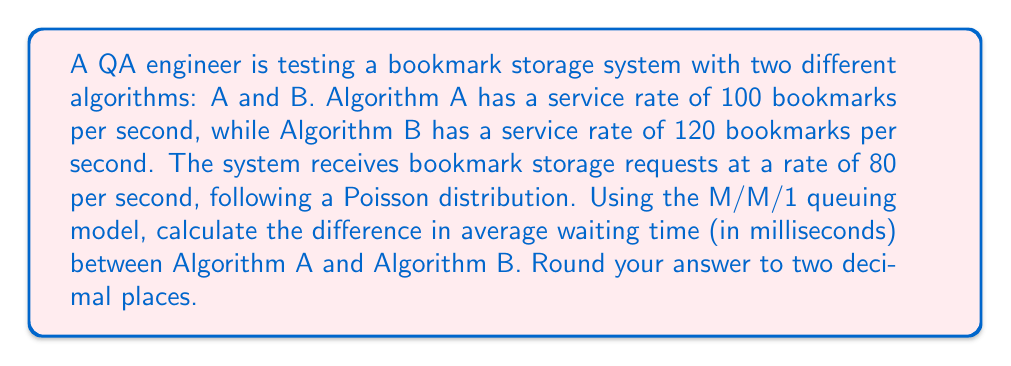Give your solution to this math problem. To solve this problem, we'll use the M/M/1 queuing model for each algorithm and compare their waiting times.

Step 1: Calculate the utilization factor (ρ) for each algorithm.
ρ = λ / μ, where λ is the arrival rate and μ is the service rate.

For Algorithm A: 
$$ \rho_A = \frac{80}{100} = 0.8 $$

For Algorithm B:
$$ \rho_B = \frac{80}{120} = \frac{2}{3} \approx 0.6667 $$

Step 2: Calculate the average waiting time (W) for each algorithm using the formula:
$$ W = \frac{\rho}{\mu(1-\rho)} $$

For Algorithm A:
$$ W_A = \frac{0.8}{100(1-0.8)} = \frac{0.8}{20} = 0.04 \text{ seconds} = 40 \text{ ms} $$

For Algorithm B:
$$ W_B = \frac{0.6667}{120(1-0.6667)} = \frac{0.6667}{40} = 0.016667 \text{ seconds} \approx 16.67 \text{ ms} $$

Step 3: Calculate the difference in waiting times.
$$ \text{Difference} = W_A - W_B = 40 - 16.67 = 23.33 \text{ ms} $$

Rounding to two decimal places, we get 23.33 ms.
Answer: 23.33 ms 